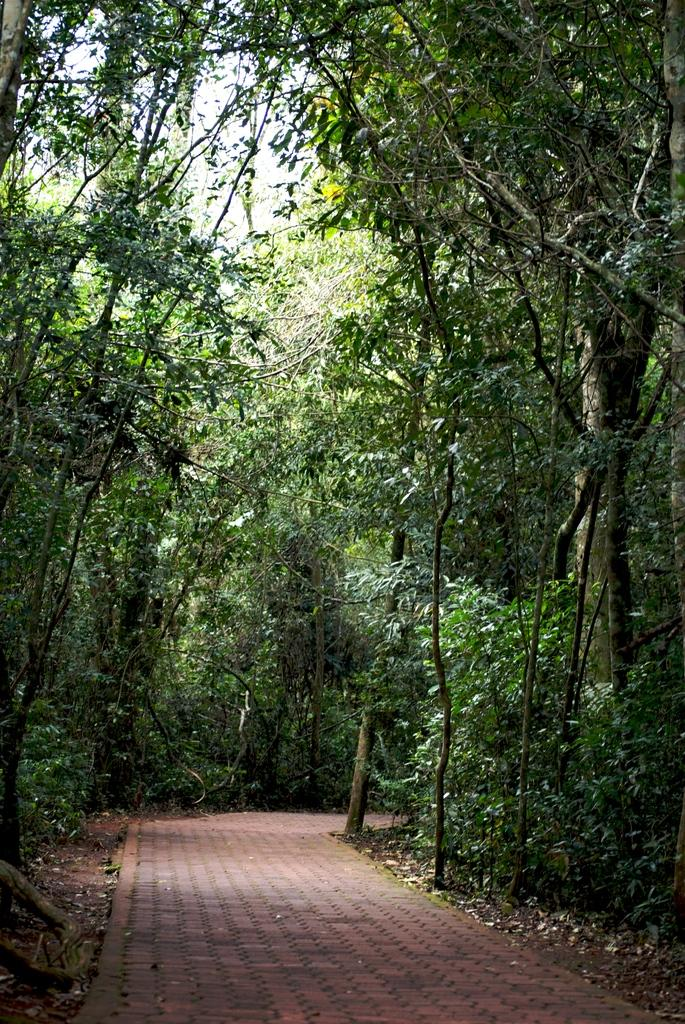What type of vegetation can be seen in the image? There are trees in the image. What is present on the ground around the trees? Dried leaves are present in the image. Is there any indication of a path or walkway in the image? Yes, there is a path visible in the image. What can be seen above the trees and path in the image? The sky is visible in the image. How many passengers are visible in the image? There are no passengers present in the image. What type of top is being worn by the trees in the image? Trees do not wear clothing, so there is no top present in the image. 